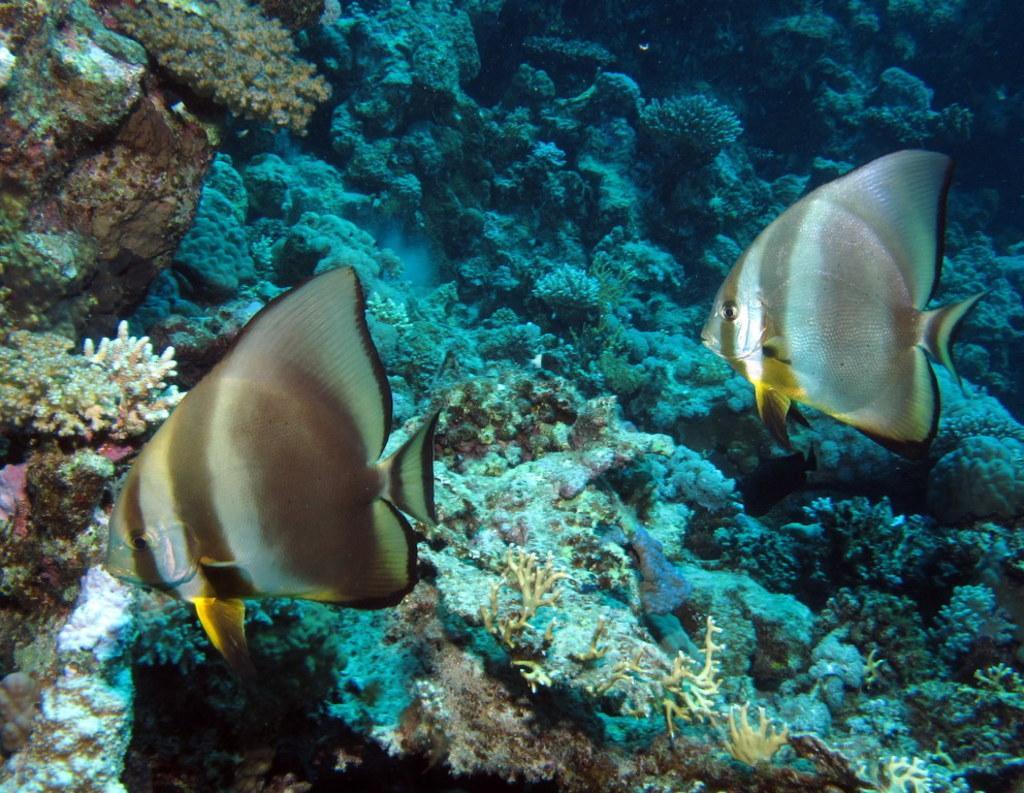Can you describe this image briefly? In this picture we can see fishes under the water and corals. 